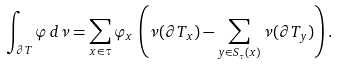<formula> <loc_0><loc_0><loc_500><loc_500>\int _ { \partial T } \varphi \, d \nu = \sum _ { x \in \tau } \varphi _ { x } \, \left ( \nu ( \partial T _ { x } ) - \sum _ { y \in S _ { \tau } ( x ) } \nu ( \partial T _ { y } ) \right ) .</formula> 